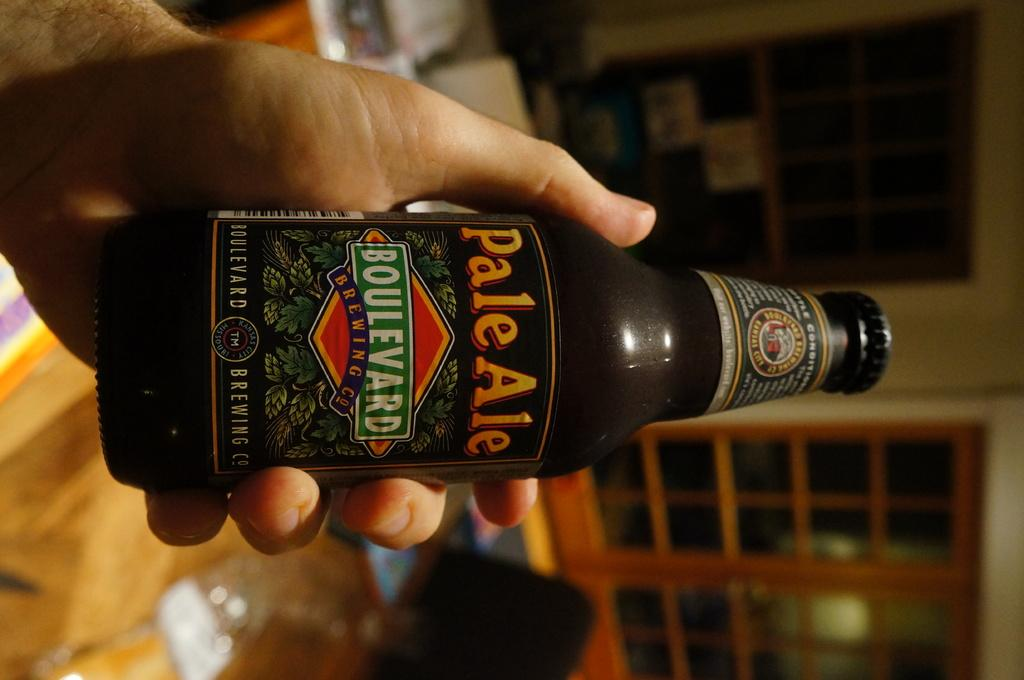<image>
Provide a brief description of the given image. a bottle of pale ale boulevard brewing company being held by someone 